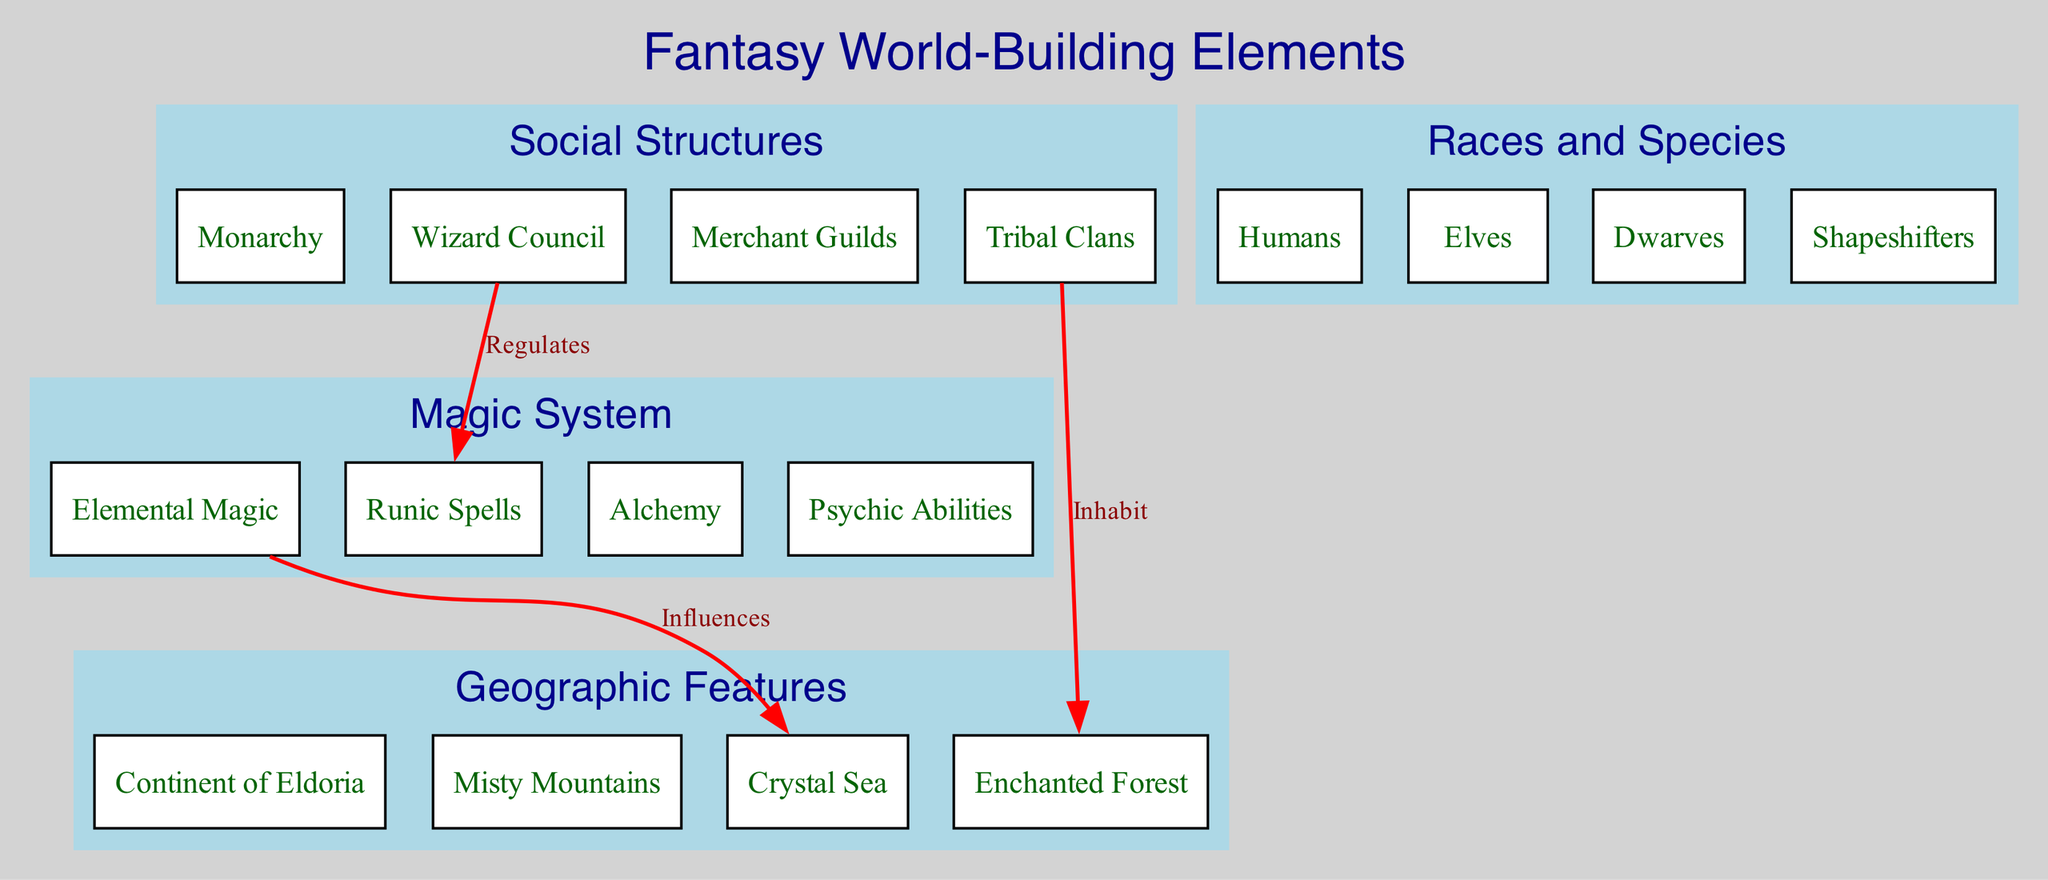What are the main categories of world-building elements? The diagram lists four main categories: Geographic Features, Magic System, Social Structures, and Races and Species. These categories help organize the various elements involved in world-building for the fantasy series.
Answer: Geographic Features, Magic System, Social Structures, Races and Species Which subcategory is associated with the Enchanted Forest? The diagram shows that the Enchanted Forest is a subcategory under Geographic Features. This indicates that the forest is considered a geographic element within the fantasy world.
Answer: Enchanted Forest How many connections are depicted in the diagram? By counting the connections listed in the diagram, there are three connections shown that illustrate relationships between different elements of the fantasy world-building.
Answer: 3 What does the Wizard Council regulate? According to the diagram, the Wizard Council regulates Runic Spells. This shows the governing role the council holds over specific magical practices within the world.
Answer: Runic Spells Which subcategory inhabits the Enchanted Forest? The diagram indicates that the Tribal Clans inhabit the Enchanted Forest, linking the social structure to the geographic feature and demonstrating the relationship between clans and their environment.
Answer: Tribal Clans What is stated about Elemental Magic's influence? The diagram states that Elemental Magic influences the Crystal Sea, illustrating a direct relationship where the magic impacts or alters the characteristics of the sea.
Answer: Crystal Sea Which race is listed alongside Humans, Elves, and Dwarves? The diagram lists Shapeshifters as a race alongside Humans, Elves, and Dwarves under the Races and Species category, indicating the diversity of beings in the fantasy world.
Answer: Shapeshifters What type of magic is included in the Magic System? The Magic System includes multiple types of magic, specifically mentioned are Elemental Magic, Runic Spells, Alchemy, and Psychic Abilities, showing the variety of magical practices present.
Answer: Elemental Magic, Runic Spells, Alchemy, Psychic Abilities Which category does the Crystal Sea fall under? The Crystal Sea is categorized under Geographic Features, which classifies it as a physical aspect of the fantasy world. This places it in the context of the world’s geography.
Answer: Geographic Features 